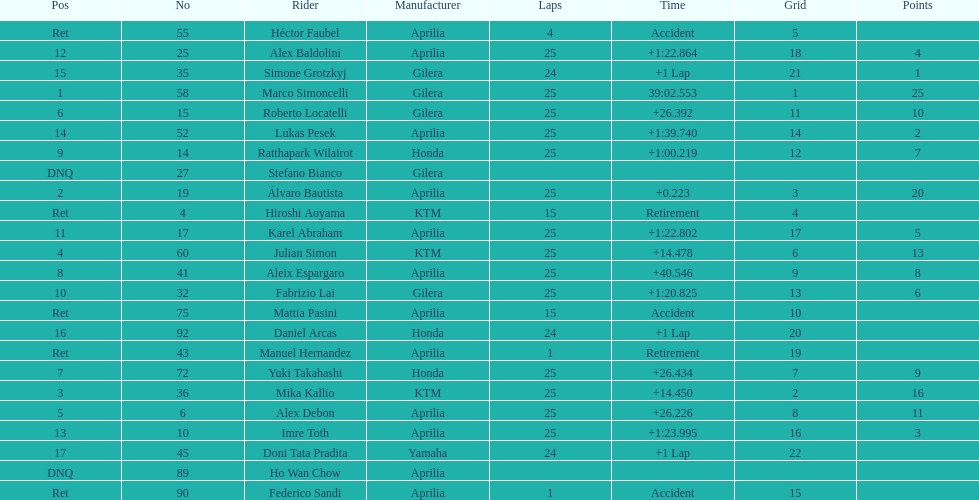Would you mind parsing the complete table? {'header': ['Pos', 'No', 'Rider', 'Manufacturer', 'Laps', 'Time', 'Grid', 'Points'], 'rows': [['Ret', '55', 'Héctor Faubel', 'Aprilia', '4', 'Accident', '5', ''], ['12', '25', 'Alex Baldolini', 'Aprilia', '25', '+1:22.864', '18', '4'], ['15', '35', 'Simone Grotzkyj', 'Gilera', '24', '+1 Lap', '21', '1'], ['1', '58', 'Marco Simoncelli', 'Gilera', '25', '39:02.553', '1', '25'], ['6', '15', 'Roberto Locatelli', 'Gilera', '25', '+26.392', '11', '10'], ['14', '52', 'Lukas Pesek', 'Aprilia', '25', '+1:39.740', '14', '2'], ['9', '14', 'Ratthapark Wilairot', 'Honda', '25', '+1:00.219', '12', '7'], ['DNQ', '27', 'Stefano Bianco', 'Gilera', '', '', '', ''], ['2', '19', 'Álvaro Bautista', 'Aprilia', '25', '+0.223', '3', '20'], ['Ret', '4', 'Hiroshi Aoyama', 'KTM', '15', 'Retirement', '4', ''], ['11', '17', 'Karel Abraham', 'Aprilia', '25', '+1:22.802', '17', '5'], ['4', '60', 'Julian Simon', 'KTM', '25', '+14.478', '6', '13'], ['8', '41', 'Aleix Espargaro', 'Aprilia', '25', '+40.546', '9', '8'], ['10', '32', 'Fabrizio Lai', 'Gilera', '25', '+1:20.825', '13', '6'], ['Ret', '75', 'Mattia Pasini', 'Aprilia', '15', 'Accident', '10', ''], ['16', '92', 'Daniel Arcas', 'Honda', '24', '+1 Lap', '20', ''], ['Ret', '43', 'Manuel Hernandez', 'Aprilia', '1', 'Retirement', '19', ''], ['7', '72', 'Yuki Takahashi', 'Honda', '25', '+26.434', '7', '9'], ['3', '36', 'Mika Kallio', 'KTM', '25', '+14.450', '2', '16'], ['5', '6', 'Alex Debon', 'Aprilia', '25', '+26.226', '8', '11'], ['13', '10', 'Imre Toth', 'Aprilia', '25', '+1:23.995', '16', '3'], ['17', '45', 'Doni Tata Pradita', 'Yamaha', '24', '+1 Lap', '22', ''], ['DNQ', '89', 'Ho Wan Chow', 'Aprilia', '', '', '', ''], ['Ret', '90', 'Federico Sandi', 'Aprilia', '1', 'Accident', '15', '']]} The total amount of riders who did not qualify 2. 